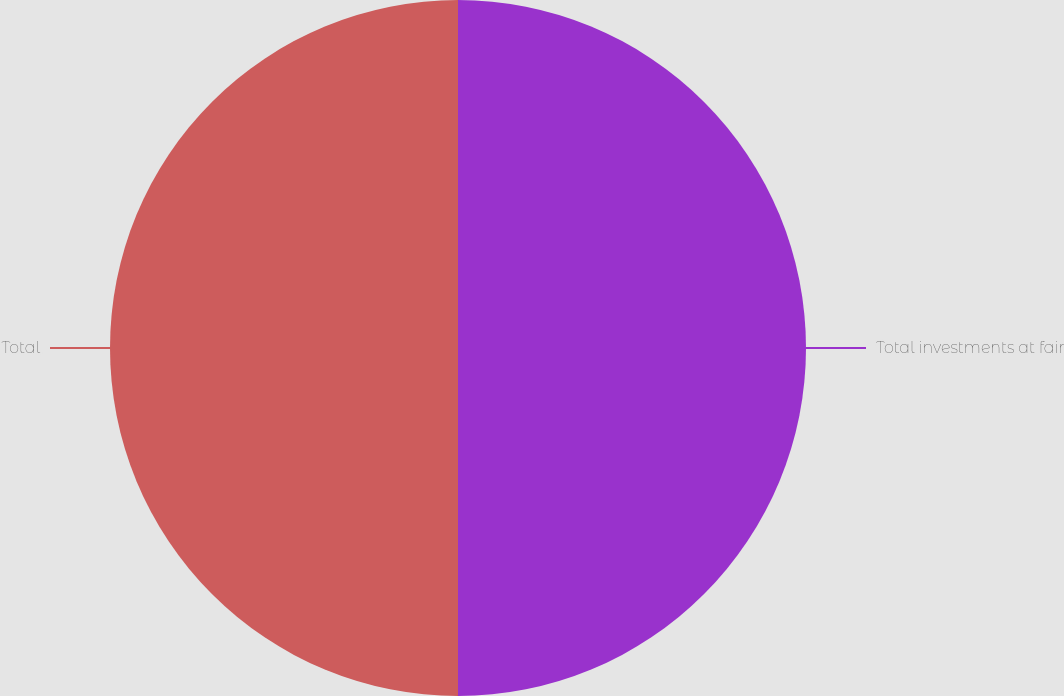<chart> <loc_0><loc_0><loc_500><loc_500><pie_chart><fcel>Total investments at fair<fcel>Total<nl><fcel>50.0%<fcel>50.0%<nl></chart> 